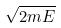<formula> <loc_0><loc_0><loc_500><loc_500>\sqrt { 2 m E }</formula> 